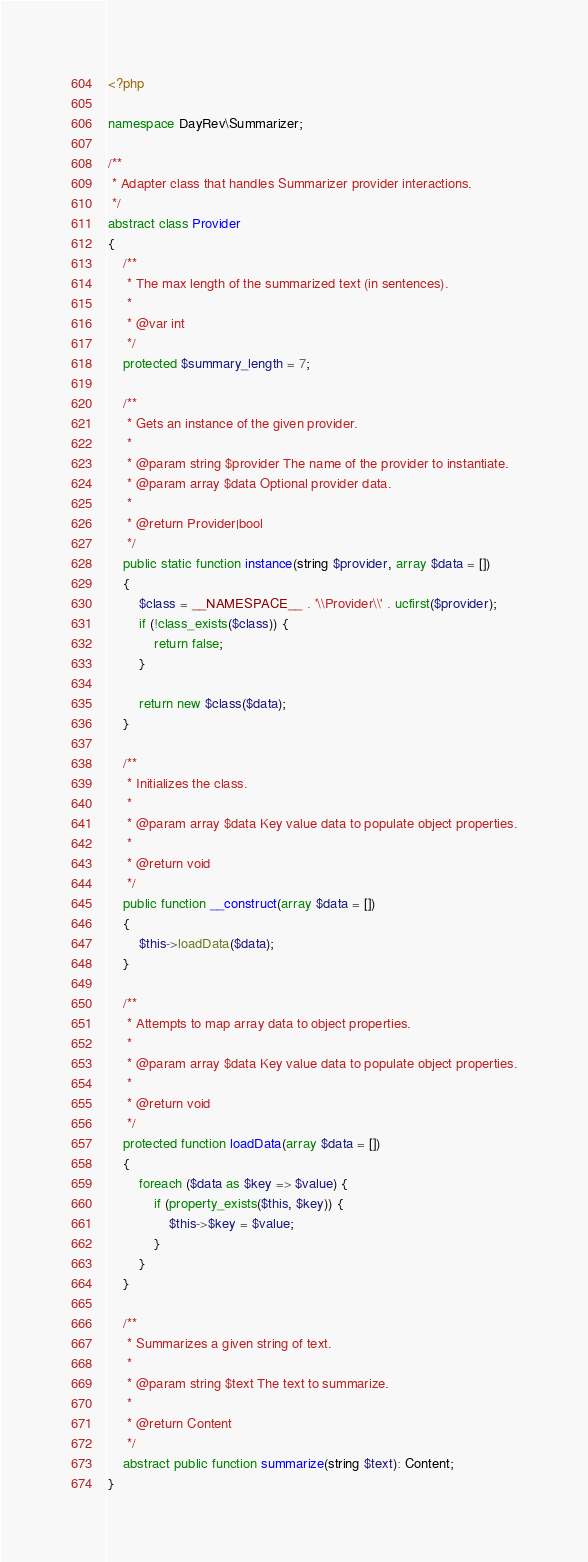<code> <loc_0><loc_0><loc_500><loc_500><_PHP_><?php

namespace DayRev\Summarizer;

/**
 * Adapter class that handles Summarizer provider interactions.
 */
abstract class Provider
{
    /**
     * The max length of the summarized text (in sentences).
     *
     * @var int
     */
    protected $summary_length = 7;

    /**
     * Gets an instance of the given provider.
     *
     * @param string $provider The name of the provider to instantiate.
     * @param array $data Optional provider data.
     *
     * @return Provider|bool
     */
    public static function instance(string $provider, array $data = [])
    {
        $class = __NAMESPACE__ . '\\Provider\\' . ucfirst($provider);
        if (!class_exists($class)) {
            return false;
        }

        return new $class($data);
    }

    /**
     * Initializes the class.
     *
     * @param array $data Key value data to populate object properties.
     *
     * @return void
     */
    public function __construct(array $data = [])
    {
        $this->loadData($data);
    }

    /**
     * Attempts to map array data to object properties.
     *
     * @param array $data Key value data to populate object properties.
     *
     * @return void
     */
    protected function loadData(array $data = [])
    {
        foreach ($data as $key => $value) {
            if (property_exists($this, $key)) {
                $this->$key = $value;
            }
        }
    }

    /**
     * Summarizes a given string of text.
     *
     * @param string $text The text to summarize.
     *
     * @return Content
     */
    abstract public function summarize(string $text): Content;
}
</code> 